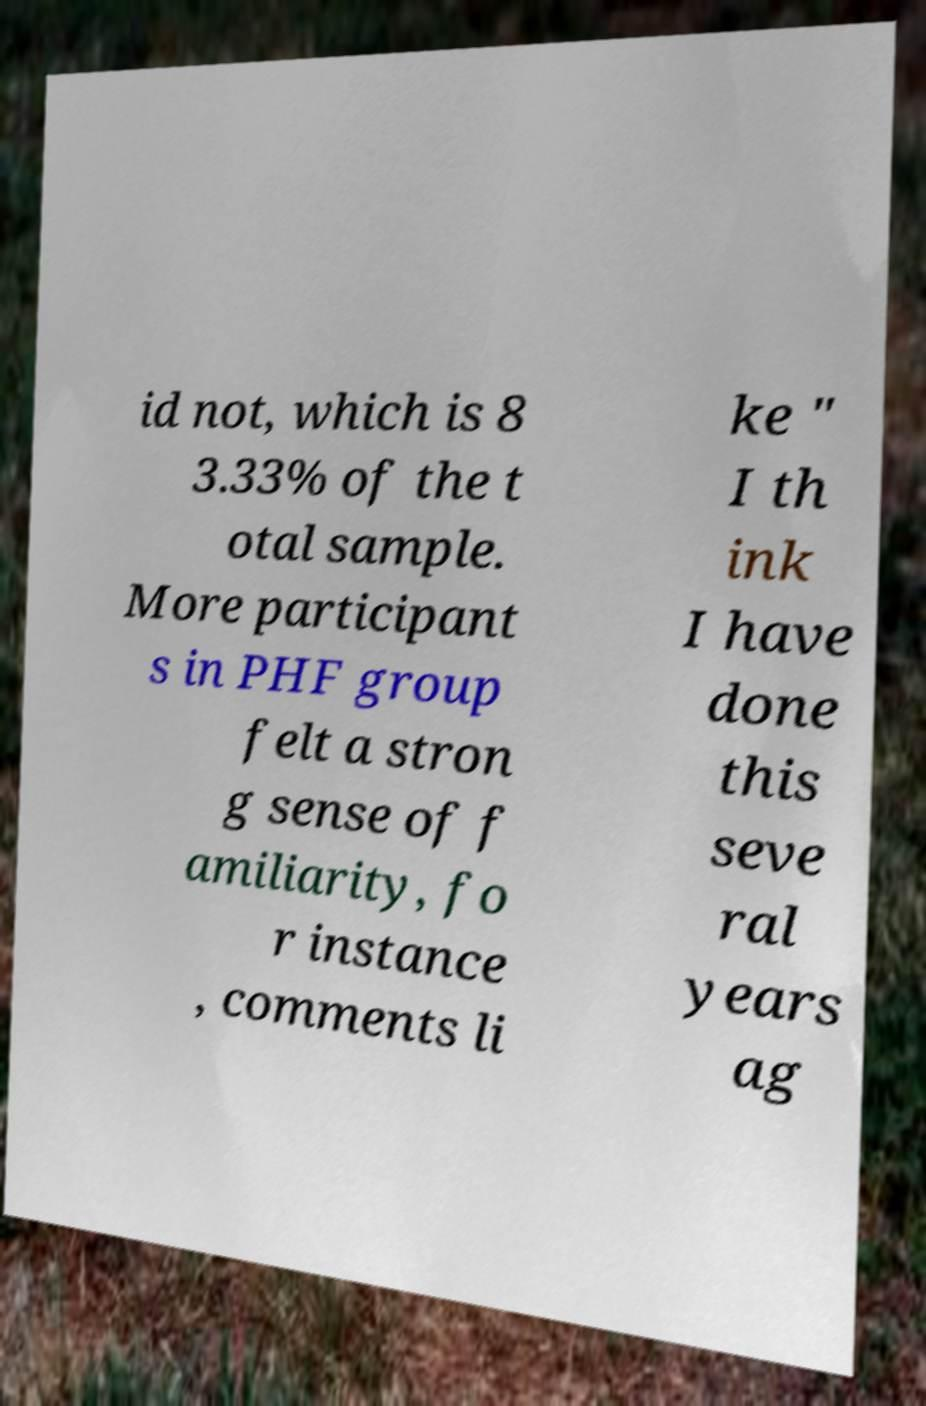Can you accurately transcribe the text from the provided image for me? id not, which is 8 3.33% of the t otal sample. More participant s in PHF group felt a stron g sense of f amiliarity, fo r instance , comments li ke " I th ink I have done this seve ral years ag 